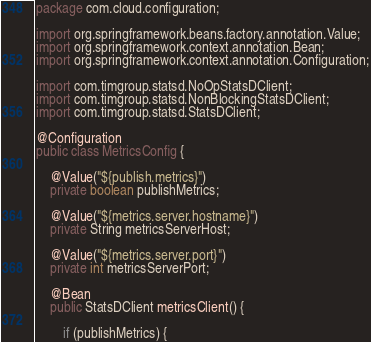Convert code to text. <code><loc_0><loc_0><loc_500><loc_500><_Java_>package com.cloud.configuration;

import org.springframework.beans.factory.annotation.Value;
import org.springframework.context.annotation.Bean;
import org.springframework.context.annotation.Configuration;

import com.timgroup.statsd.NoOpStatsDClient;
import com.timgroup.statsd.NonBlockingStatsDClient;
import com.timgroup.statsd.StatsDClient;

@Configuration
public class MetricsConfig {

	@Value("${publish.metrics}")
    private boolean publishMetrics;

    @Value("${metrics.server.hostname}")
    private String metricsServerHost;

    @Value("${metrics.server.port}")
    private int metricsServerPort;

    @Bean
    public StatsDClient metricsClient() {

        if (publishMetrics) {</code> 